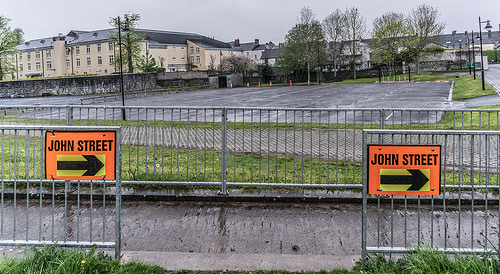<image>
Is the sign behind the fence? No. The sign is not behind the fence. From this viewpoint, the sign appears to be positioned elsewhere in the scene. 